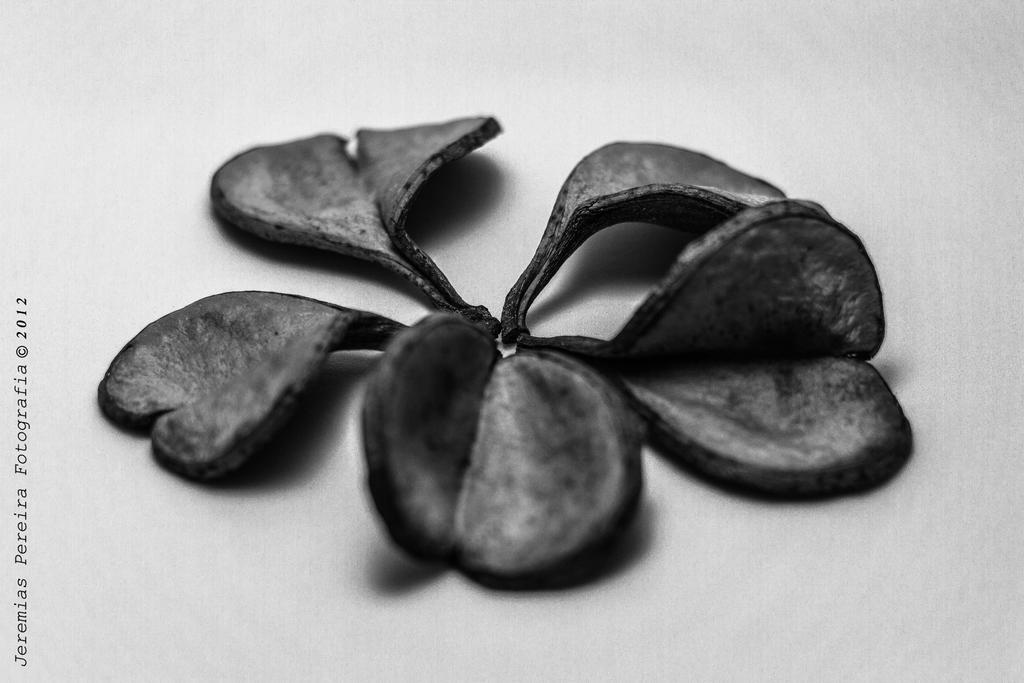How would you summarize this image in a sentence or two? In this image I can see the black color flower on the white color surface. I can also see something is written on it. 